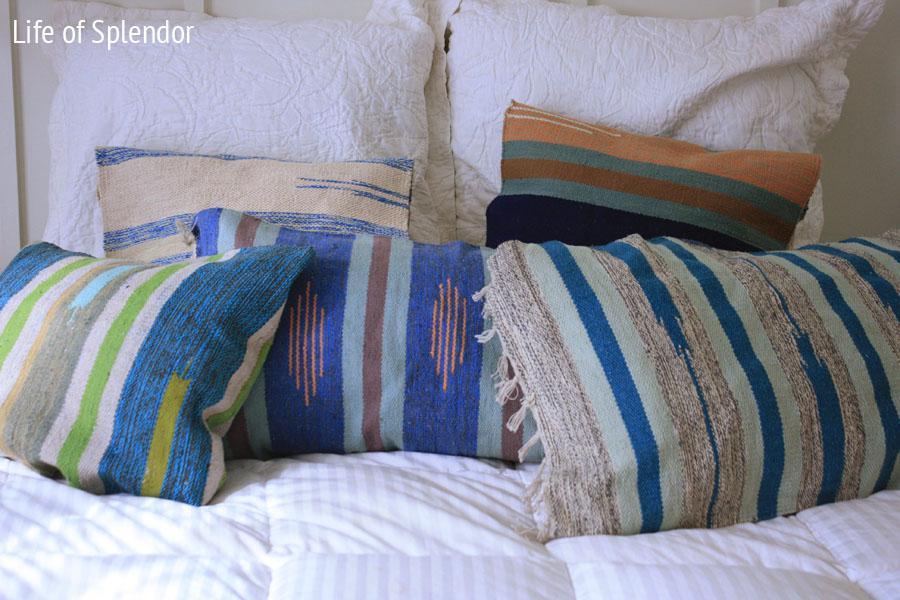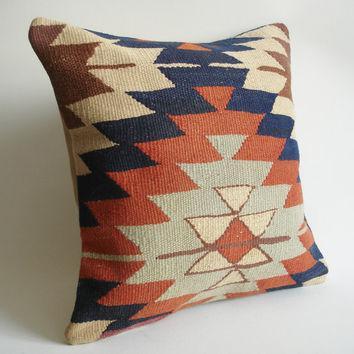The first image is the image on the left, the second image is the image on the right. For the images displayed, is the sentence "One image contains a single square pillow with Aztec-style geometric print, and the other image contains at least three pillows with coordinating geometric prints." factually correct? Answer yes or no. Yes. The first image is the image on the left, the second image is the image on the right. Assess this claim about the two images: "In at least one image there is only a single pillow standing up with some triangle patterns sewn into it.". Correct or not? Answer yes or no. Yes. 